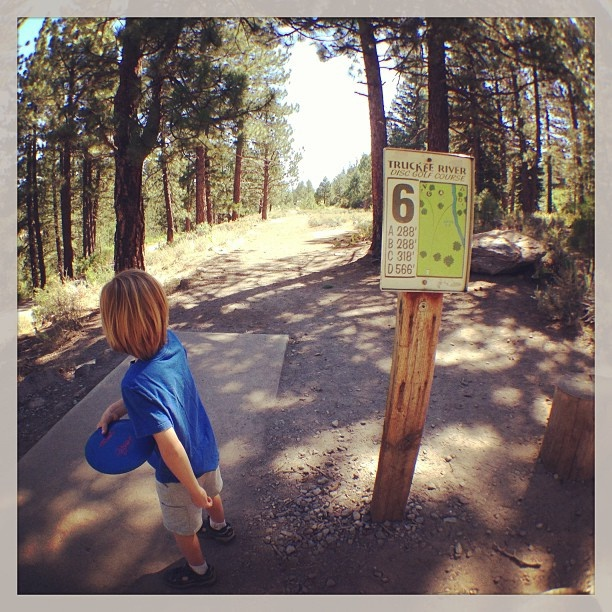Describe the objects in this image and their specific colors. I can see people in lightgray, maroon, gray, navy, and black tones and frisbee in lightgray, navy, purple, and gray tones in this image. 